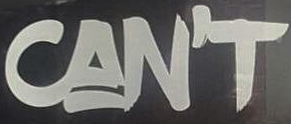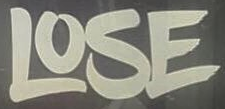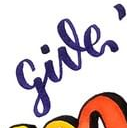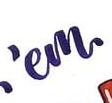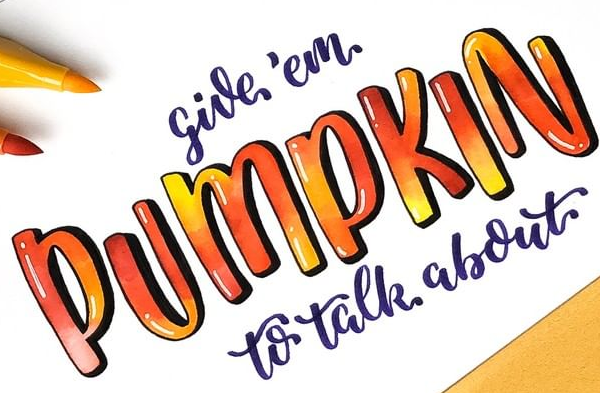Identify the words shown in these images in order, separated by a semicolon. CAN'T; LOSE; give; 'em; PUMPKIN 